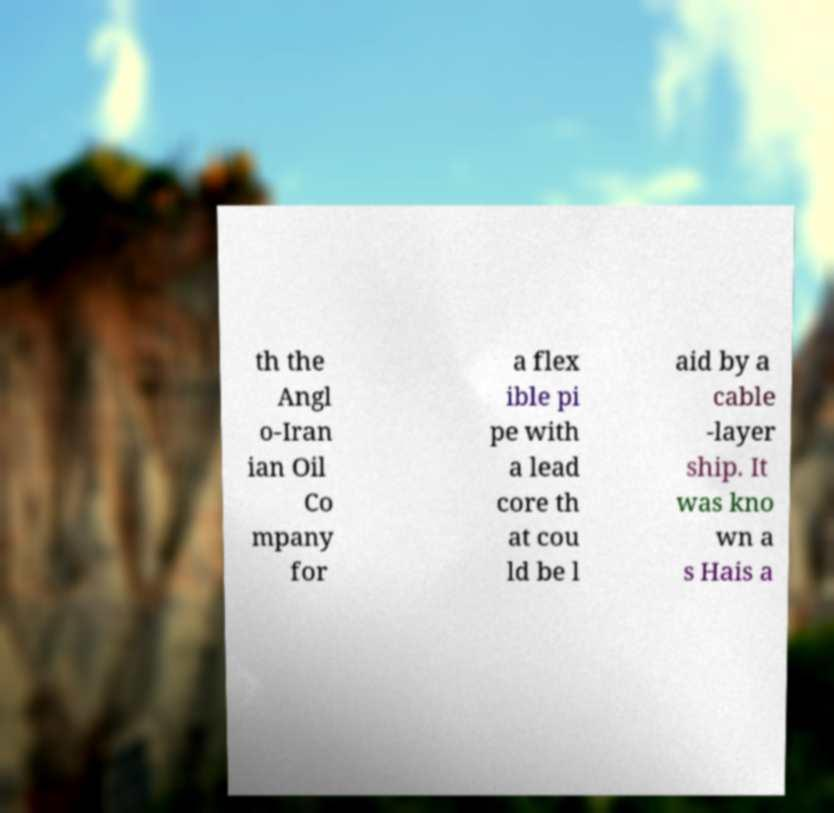For documentation purposes, I need the text within this image transcribed. Could you provide that? th the Angl o-Iran ian Oil Co mpany for a flex ible pi pe with a lead core th at cou ld be l aid by a cable -layer ship. It was kno wn a s Hais a 